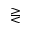<formula> <loc_0><loc_0><loc_500><loc_500>> r e q l e s s</formula> 